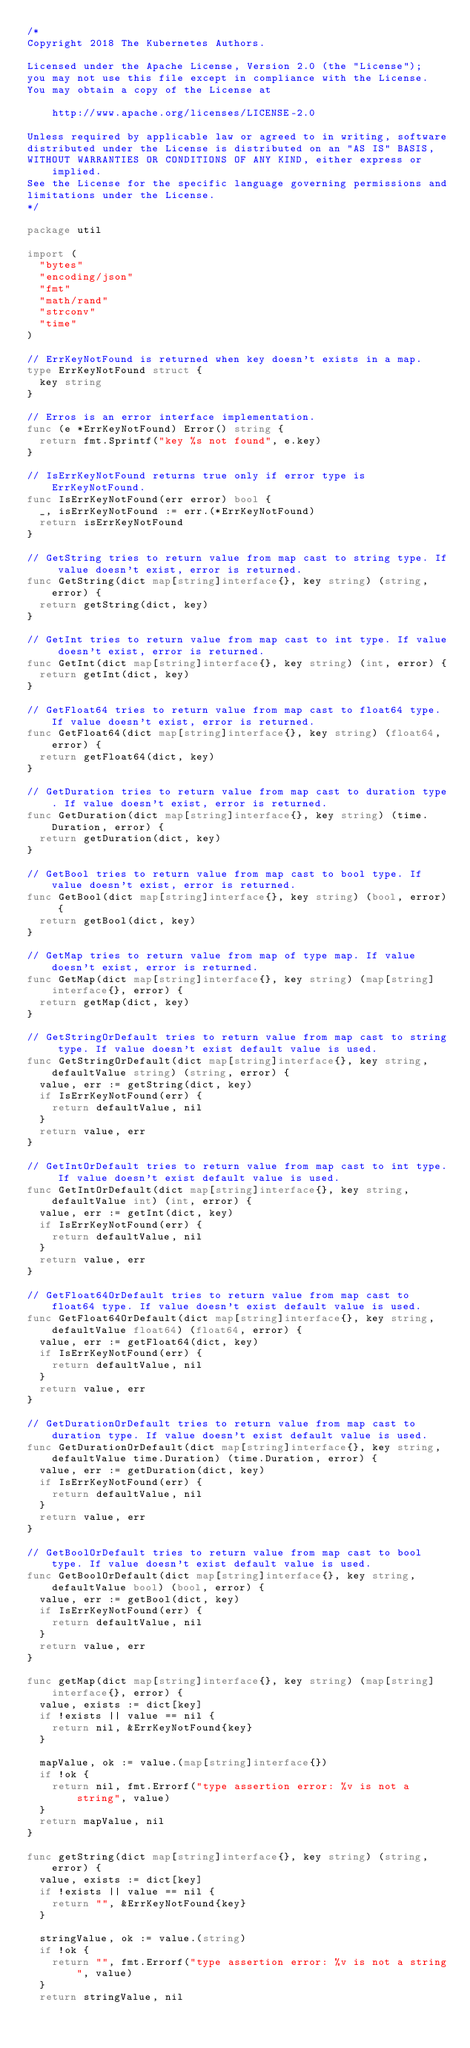Convert code to text. <code><loc_0><loc_0><loc_500><loc_500><_Go_>/*
Copyright 2018 The Kubernetes Authors.

Licensed under the Apache License, Version 2.0 (the "License");
you may not use this file except in compliance with the License.
You may obtain a copy of the License at

    http://www.apache.org/licenses/LICENSE-2.0

Unless required by applicable law or agreed to in writing, software
distributed under the License is distributed on an "AS IS" BASIS,
WITHOUT WARRANTIES OR CONDITIONS OF ANY KIND, either express or implied.
See the License for the specific language governing permissions and
limitations under the License.
*/

package util

import (
	"bytes"
	"encoding/json"
	"fmt"
	"math/rand"
	"strconv"
	"time"
)

// ErrKeyNotFound is returned when key doesn't exists in a map.
type ErrKeyNotFound struct {
	key string
}

// Erros is an error interface implementation.
func (e *ErrKeyNotFound) Error() string {
	return fmt.Sprintf("key %s not found", e.key)
}

// IsErrKeyNotFound returns true only if error type is ErrKeyNotFound.
func IsErrKeyNotFound(err error) bool {
	_, isErrKeyNotFound := err.(*ErrKeyNotFound)
	return isErrKeyNotFound
}

// GetString tries to return value from map cast to string type. If value doesn't exist, error is returned.
func GetString(dict map[string]interface{}, key string) (string, error) {
	return getString(dict, key)
}

// GetInt tries to return value from map cast to int type. If value doesn't exist, error is returned.
func GetInt(dict map[string]interface{}, key string) (int, error) {
	return getInt(dict, key)
}

// GetFloat64 tries to return value from map cast to float64 type. If value doesn't exist, error is returned.
func GetFloat64(dict map[string]interface{}, key string) (float64, error) {
	return getFloat64(dict, key)
}

// GetDuration tries to return value from map cast to duration type. If value doesn't exist, error is returned.
func GetDuration(dict map[string]interface{}, key string) (time.Duration, error) {
	return getDuration(dict, key)
}

// GetBool tries to return value from map cast to bool type. If value doesn't exist, error is returned.
func GetBool(dict map[string]interface{}, key string) (bool, error) {
	return getBool(dict, key)
}

// GetMap tries to return value from map of type map. If value doesn't exist, error is returned.
func GetMap(dict map[string]interface{}, key string) (map[string]interface{}, error) {
	return getMap(dict, key)
}

// GetStringOrDefault tries to return value from map cast to string type. If value doesn't exist default value is used.
func GetStringOrDefault(dict map[string]interface{}, key string, defaultValue string) (string, error) {
	value, err := getString(dict, key)
	if IsErrKeyNotFound(err) {
		return defaultValue, nil
	}
	return value, err
}

// GetIntOrDefault tries to return value from map cast to int type. If value doesn't exist default value is used.
func GetIntOrDefault(dict map[string]interface{}, key string, defaultValue int) (int, error) {
	value, err := getInt(dict, key)
	if IsErrKeyNotFound(err) {
		return defaultValue, nil
	}
	return value, err
}

// GetFloat64OrDefault tries to return value from map cast to float64 type. If value doesn't exist default value is used.
func GetFloat64OrDefault(dict map[string]interface{}, key string, defaultValue float64) (float64, error) {
	value, err := getFloat64(dict, key)
	if IsErrKeyNotFound(err) {
		return defaultValue, nil
	}
	return value, err
}

// GetDurationOrDefault tries to return value from map cast to duration type. If value doesn't exist default value is used.
func GetDurationOrDefault(dict map[string]interface{}, key string, defaultValue time.Duration) (time.Duration, error) {
	value, err := getDuration(dict, key)
	if IsErrKeyNotFound(err) {
		return defaultValue, nil
	}
	return value, err
}

// GetBoolOrDefault tries to return value from map cast to bool type. If value doesn't exist default value is used.
func GetBoolOrDefault(dict map[string]interface{}, key string, defaultValue bool) (bool, error) {
	value, err := getBool(dict, key)
	if IsErrKeyNotFound(err) {
		return defaultValue, nil
	}
	return value, err
}

func getMap(dict map[string]interface{}, key string) (map[string]interface{}, error) {
	value, exists := dict[key]
	if !exists || value == nil {
		return nil, &ErrKeyNotFound{key}
	}

	mapValue, ok := value.(map[string]interface{})
	if !ok {
		return nil, fmt.Errorf("type assertion error: %v is not a string", value)
	}
	return mapValue, nil
}

func getString(dict map[string]interface{}, key string) (string, error) {
	value, exists := dict[key]
	if !exists || value == nil {
		return "", &ErrKeyNotFound{key}
	}

	stringValue, ok := value.(string)
	if !ok {
		return "", fmt.Errorf("type assertion error: %v is not a string", value)
	}
	return stringValue, nil</code> 